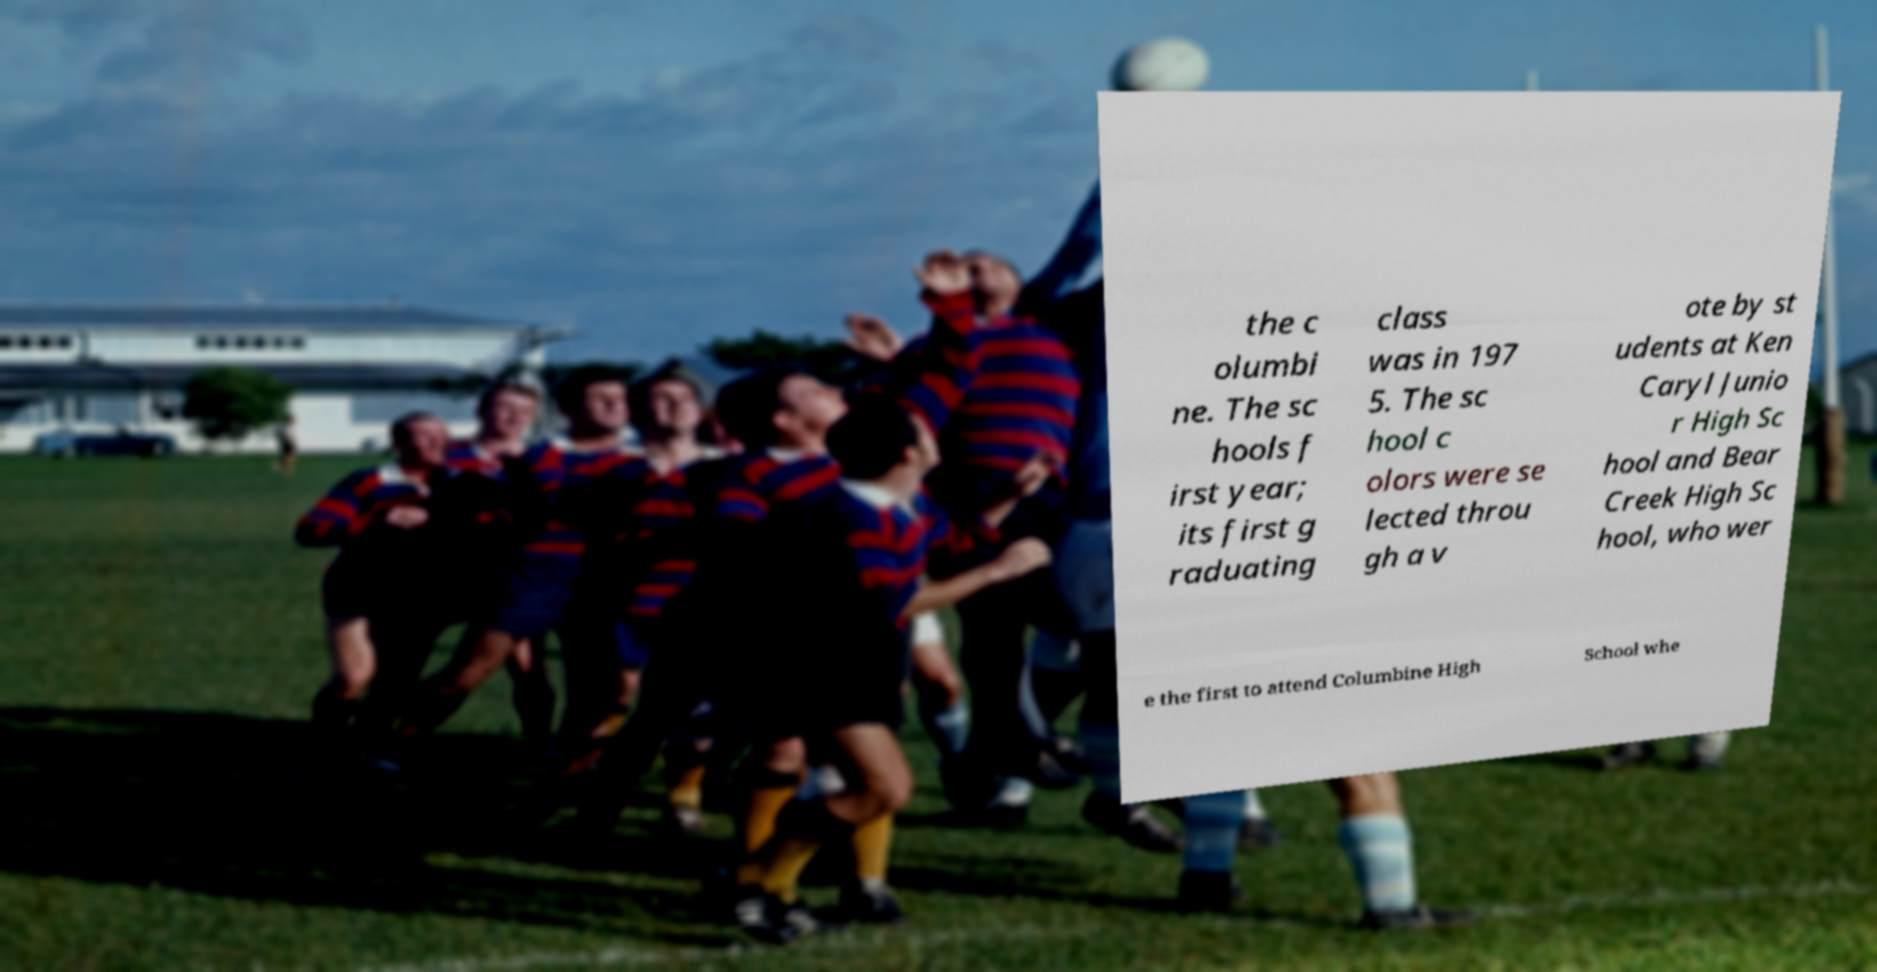Please read and relay the text visible in this image. What does it say? the c olumbi ne. The sc hools f irst year; its first g raduating class was in 197 5. The sc hool c olors were se lected throu gh a v ote by st udents at Ken Caryl Junio r High Sc hool and Bear Creek High Sc hool, who wer e the first to attend Columbine High School whe 